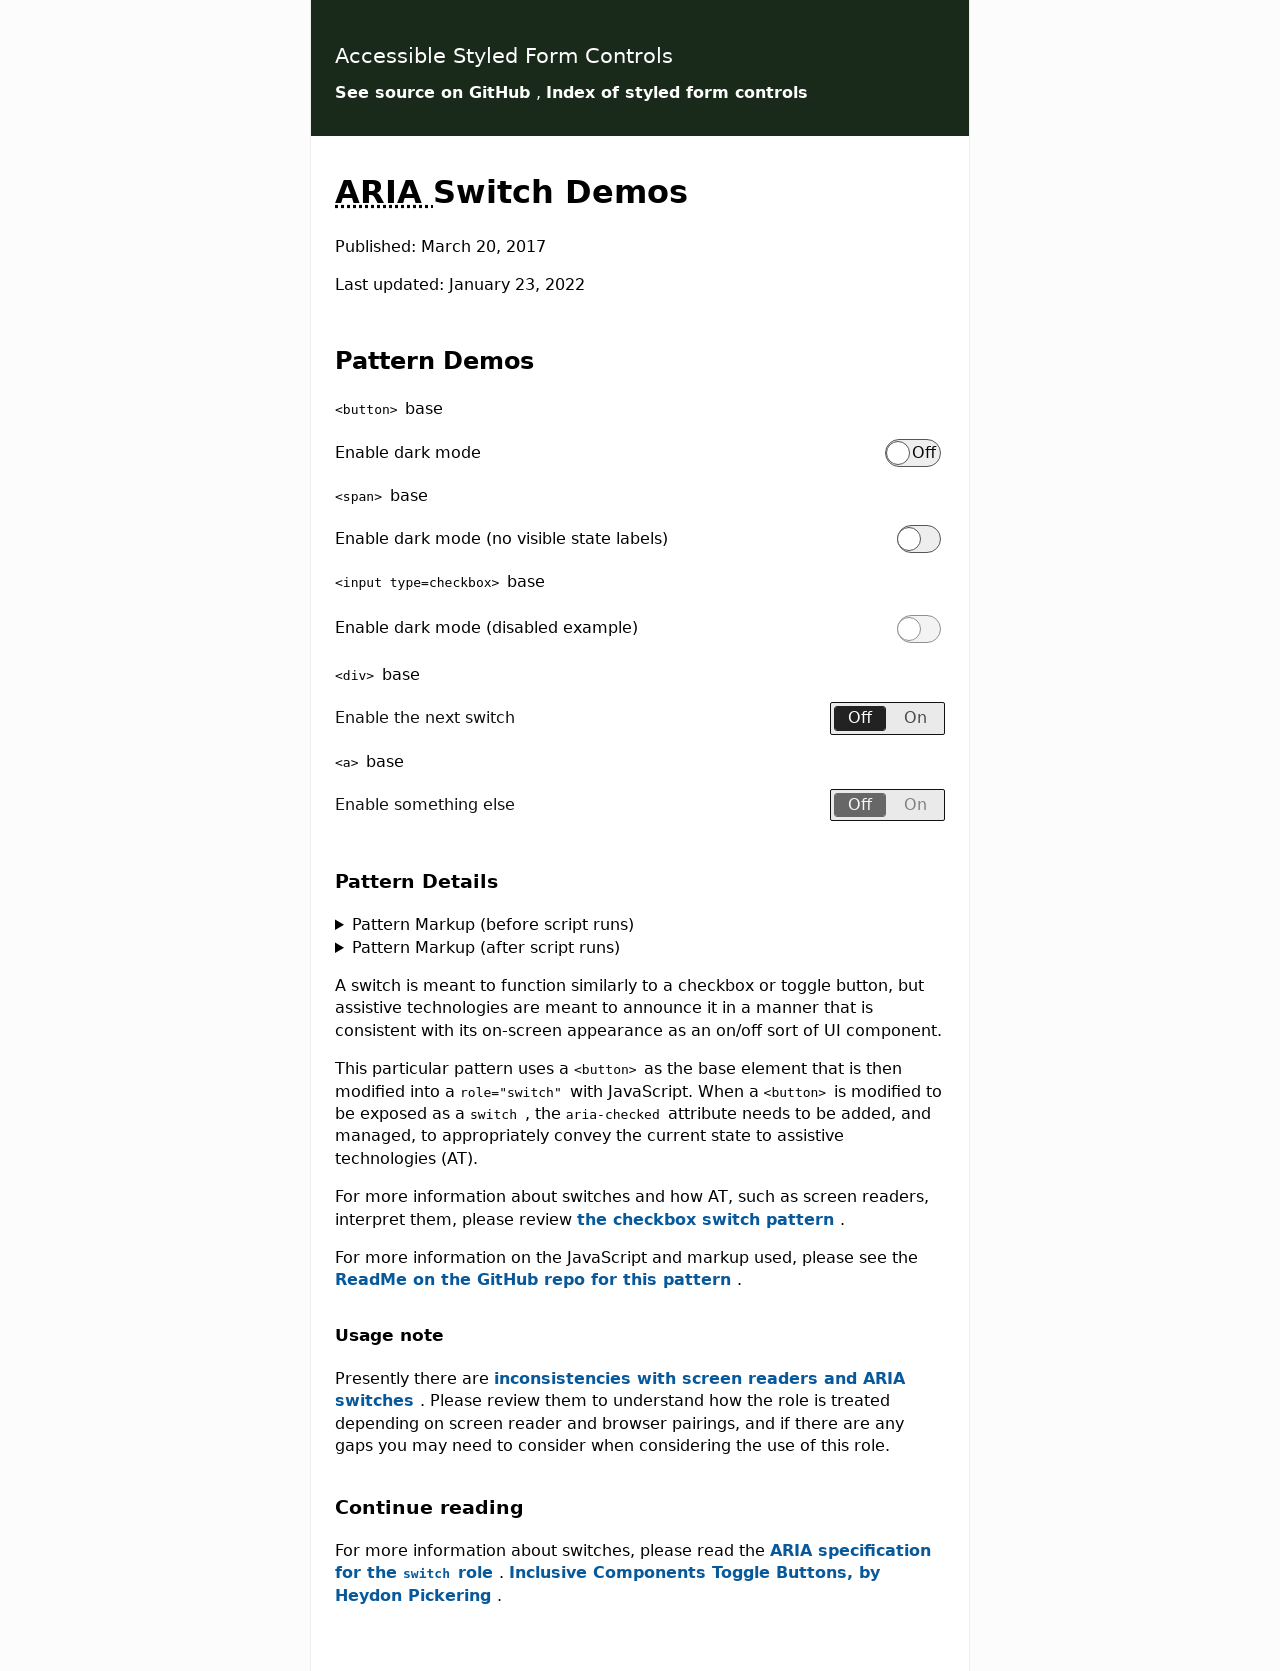Could you guide me through the process of developing this website with HTML? Certainly! The website in the image appears to feature switch demos using ARIA. To develop it, start with a basic HTML structure and include links to your CSS for styling. Each switch component, like those shown for enabling dark mode or other features, can be created using button elements with 'aria-checked' attributes manipulated via JavaScript to handle their state changes. Ensure also to embed proper ARIA roles and attributes to enhance accessibility. Here's a simplified example section of HTML code you can use:

<!DOCTYPE html>
<html lang="en">
<head>
    <title>Switch Demo</title>
</head>
<body>
    <button aria-checked="false" onclick="toggleSwitch(this)">Enable Feature</button>
    <script>
        function toggleSwitch(element) {
            element.setAttribute('aria-checked', element.getAttribute('aria-checked') === 'false' ? 'true' : 'false');
        }
    </script>
</body>
</html>

This code establishes a simple toggle switch. The JavaScript function toggles the 'aria-checked' state upon clicking the button, reflecting the enabled or disabled state visually and in assistive technologies. 